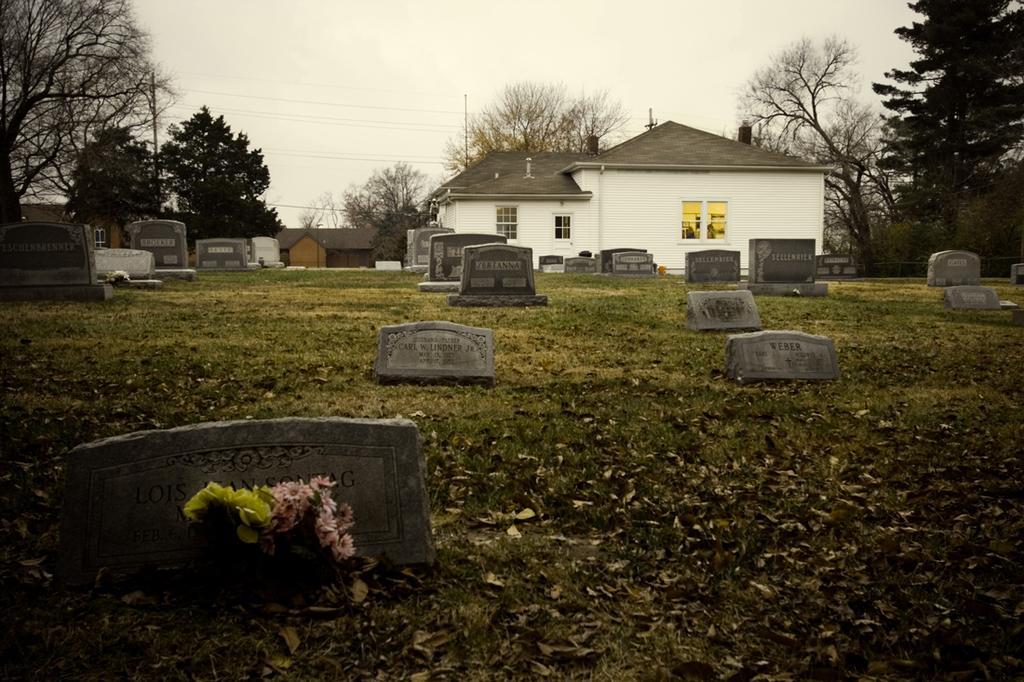Could you give a brief overview of what you see in this image? At the bottom of the image we can see graves and there are flowers. In the background there is a shed and trees. At the top there is sky. 